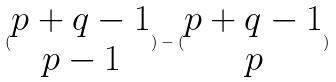Convert formula to latex. <formula><loc_0><loc_0><loc_500><loc_500>( \begin{matrix} p + q - 1 \\ p - 1 \end{matrix} ) - ( \begin{matrix} p + q - 1 \\ p \end{matrix} )</formula> 